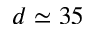Convert formula to latex. <formula><loc_0><loc_0><loc_500><loc_500>d \simeq 3 5</formula> 